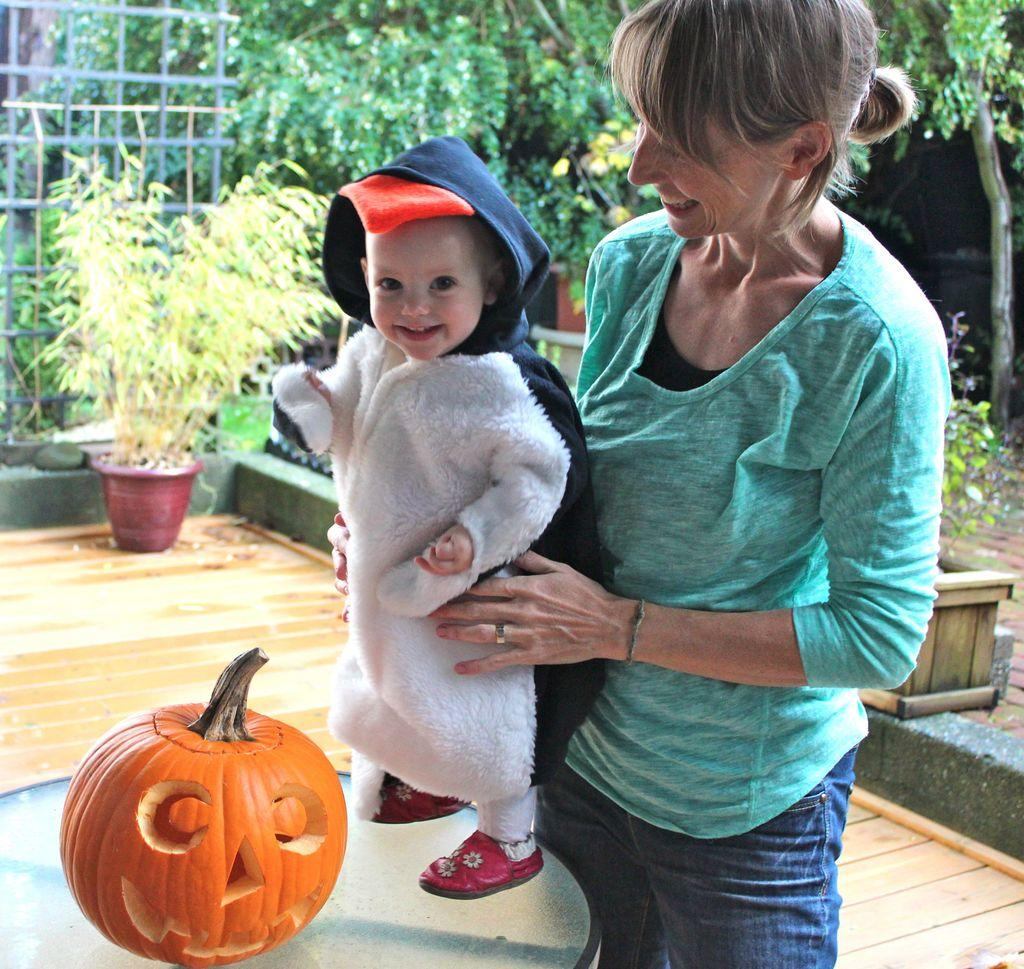Who is the main subject in the image? There is a lady in the center of the image. Can you describe any other people in the image? Yes, there is a girl in the image. What object can be seen on the table? There is a pumpkin on the table. What type of plant is present in the image? There is a plant in a flower pot. What can be seen in the background of the image? There are trees in the background of the image. How many snails are crawling on the pumpkin in the image? There are no snails visible in the image; it only shows a pumpkin on the table. What type of pie is being served on the table in the image? There is no pie present in the image; it only shows a pumpkin on the table. 